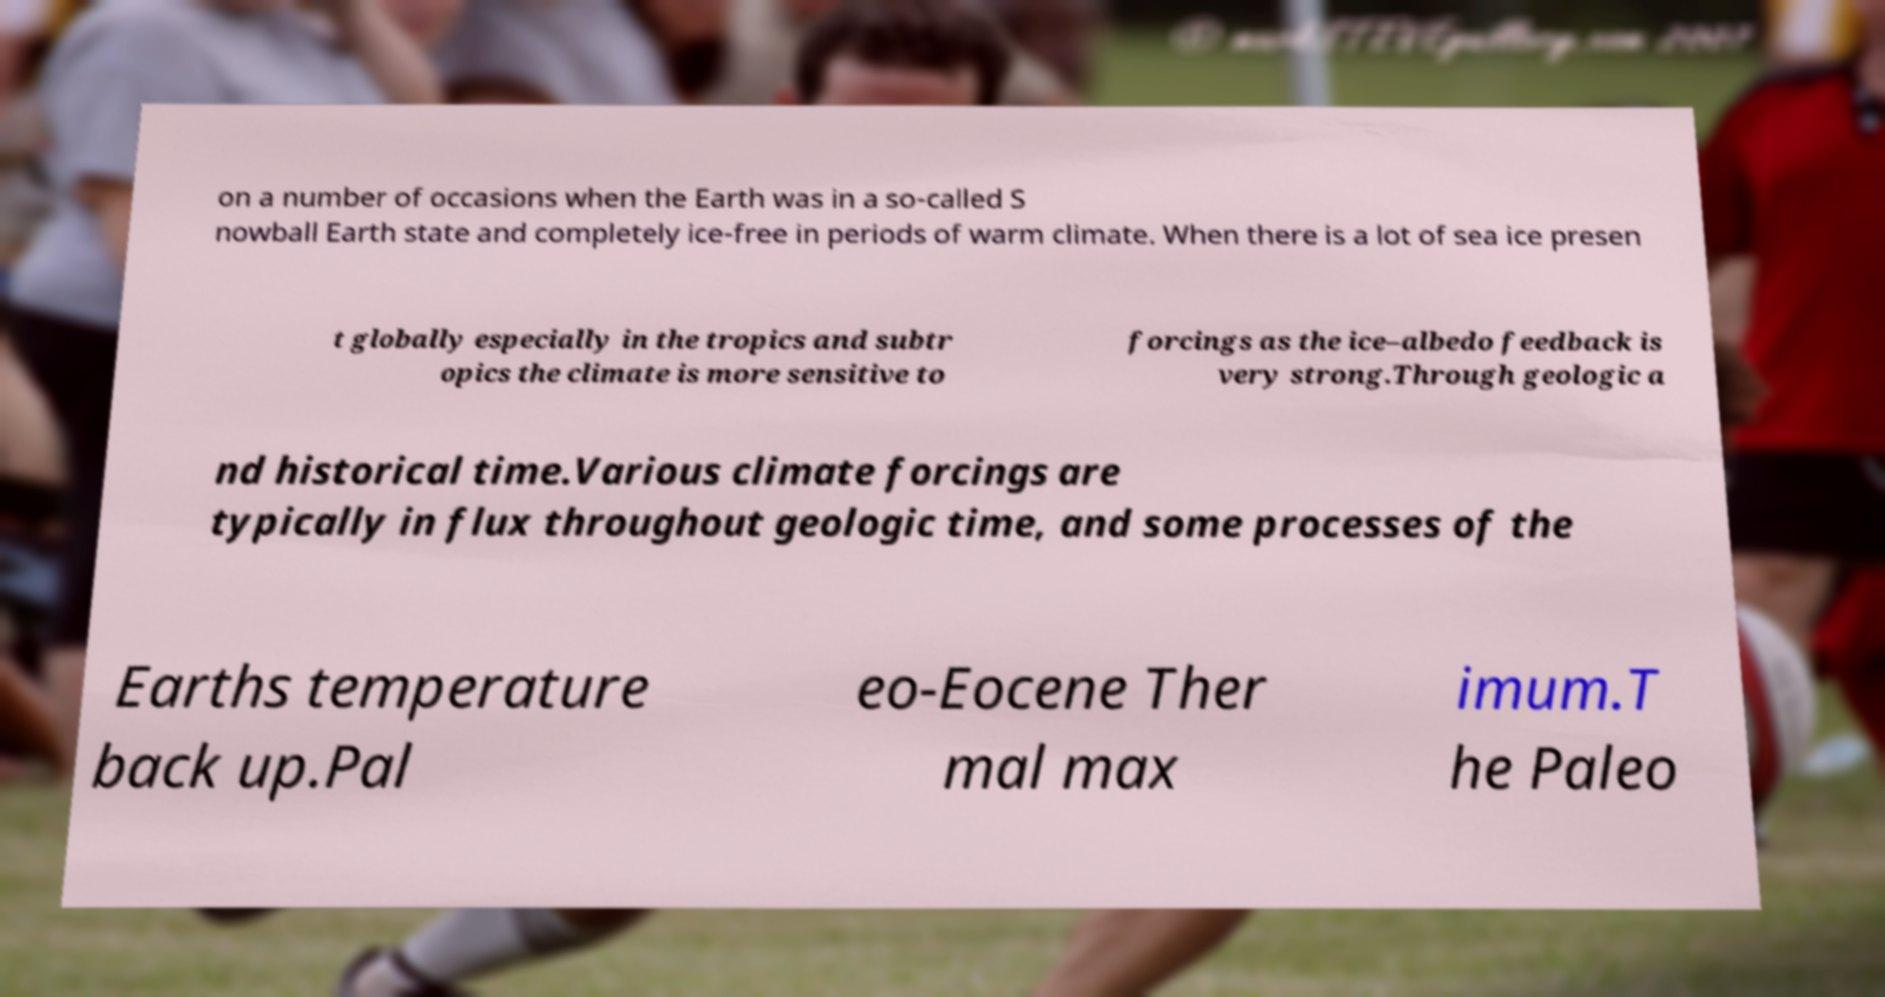Please read and relay the text visible in this image. What does it say? on a number of occasions when the Earth was in a so-called S nowball Earth state and completely ice-free in periods of warm climate. When there is a lot of sea ice presen t globally especially in the tropics and subtr opics the climate is more sensitive to forcings as the ice–albedo feedback is very strong.Through geologic a nd historical time.Various climate forcings are typically in flux throughout geologic time, and some processes of the Earths temperature back up.Pal eo-Eocene Ther mal max imum.T he Paleo 